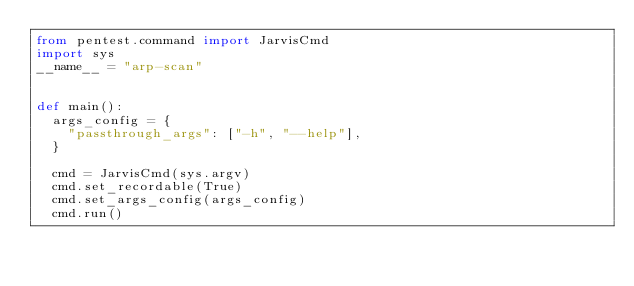Convert code to text. <code><loc_0><loc_0><loc_500><loc_500><_Python_>from pentest.command import JarvisCmd
import sys
__name__ = "arp-scan"


def main():
	args_config = {
		"passthrough_args": ["-h", "--help"],
	}

	cmd = JarvisCmd(sys.argv)
	cmd.set_recordable(True)
	cmd.set_args_config(args_config)
	cmd.run()
</code> 